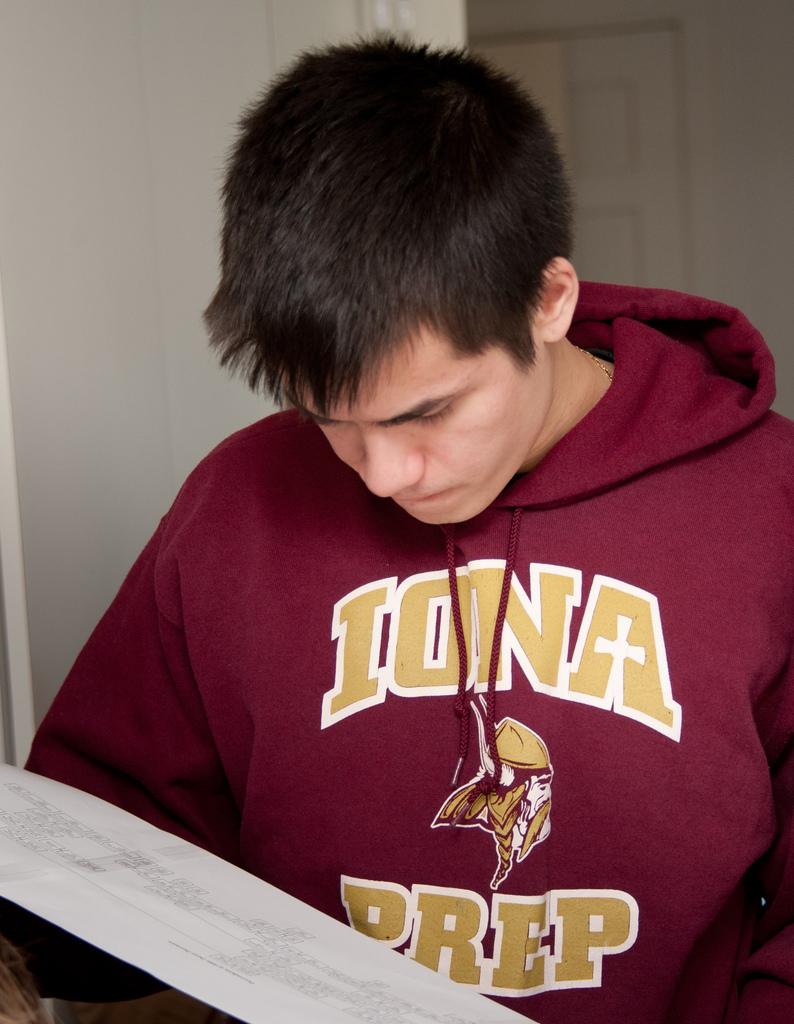What is the name of the school?
Give a very brief answer. Iona prep. Which class type does he attend?
Offer a terse response. Iona prep. 